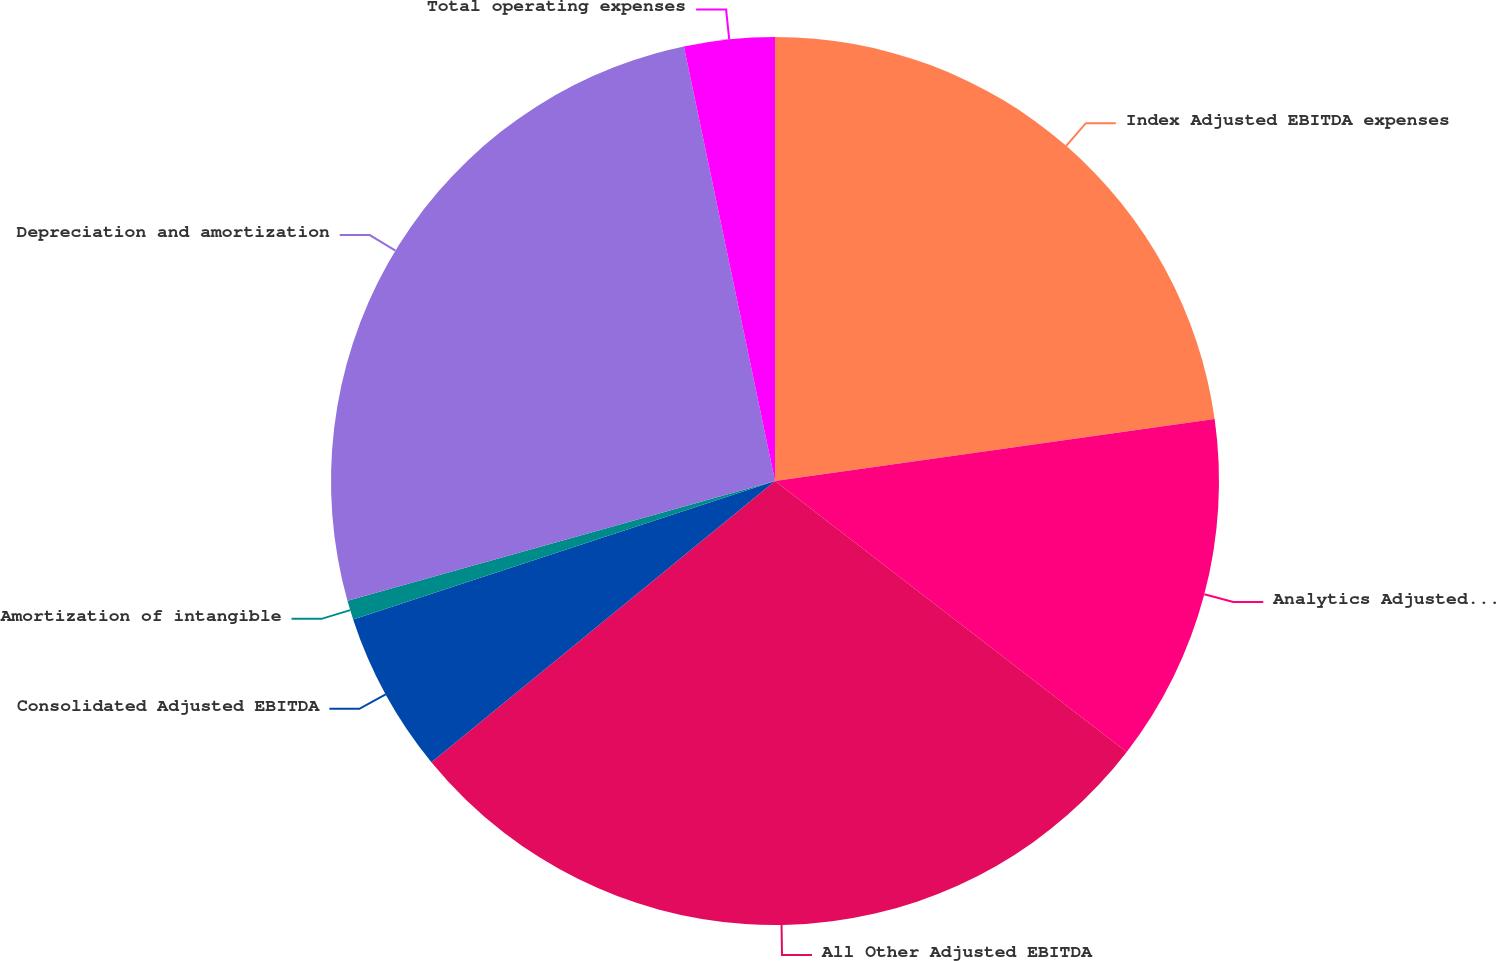<chart> <loc_0><loc_0><loc_500><loc_500><pie_chart><fcel>Index Adjusted EBITDA expenses<fcel>Analytics Adjusted EBITDA<fcel>All Other Adjusted EBITDA<fcel>Consolidated Adjusted EBITDA<fcel>Amortization of intangible<fcel>Depreciation and amortization<fcel>Total operating expenses<nl><fcel>22.77%<fcel>12.68%<fcel>28.64%<fcel>5.87%<fcel>0.7%<fcel>26.06%<fcel>3.29%<nl></chart> 